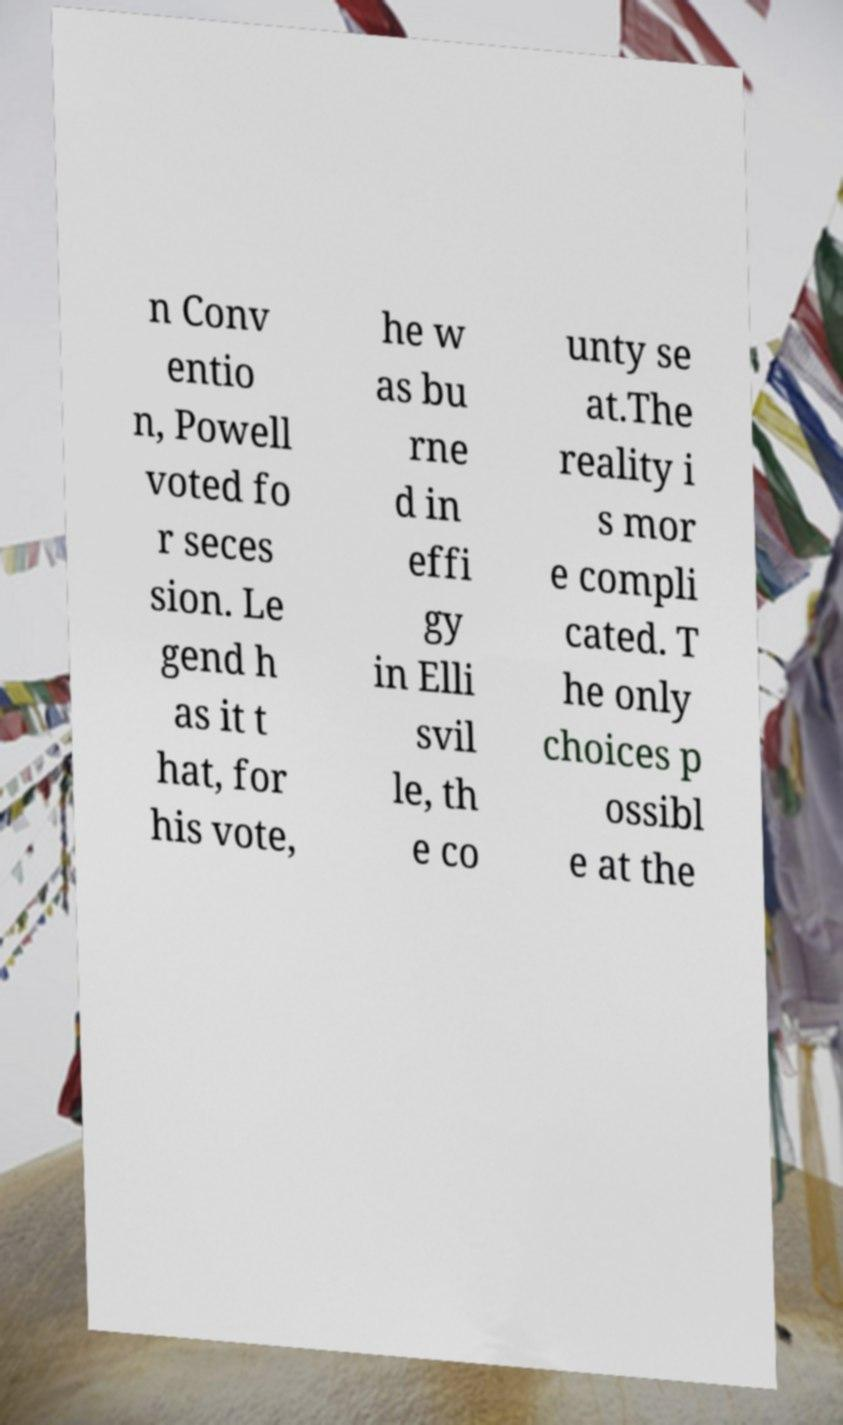Please identify and transcribe the text found in this image. n Conv entio n, Powell voted fo r seces sion. Le gend h as it t hat, for his vote, he w as bu rne d in effi gy in Elli svil le, th e co unty se at.The reality i s mor e compli cated. T he only choices p ossibl e at the 